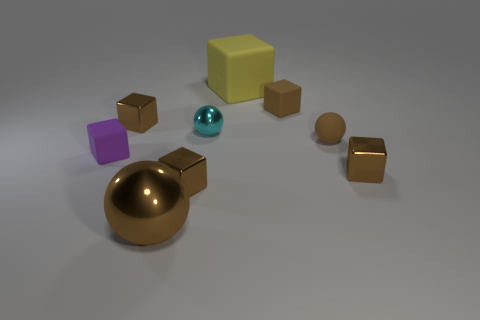Is the large metal ball the same color as the matte ball?
Offer a very short reply. Yes. How many other objects are there of the same color as the big metal thing?
Your response must be concise. 5. There is a tiny rubber cube on the right side of the yellow matte object; is its color the same as the rubber sphere?
Provide a succinct answer. Yes. There is a brown sphere that is the same size as the yellow block; what is it made of?
Your answer should be very brief. Metal. Is the number of blocks that are in front of the large cube the same as the number of small purple cubes that are behind the purple cube?
Your answer should be very brief. No. How many large brown objects are to the left of the tiny brown shiny cube that is to the left of the brown sphere to the left of the big yellow matte object?
Your answer should be compact. 0. Is the color of the matte sphere the same as the metallic block that is left of the big brown sphere?
Give a very brief answer. Yes. What is the size of the brown cube that is the same material as the purple cube?
Provide a succinct answer. Small. Are there more big things in front of the large yellow matte object than large red matte things?
Make the answer very short. Yes. There is a brown ball that is right of the small matte block that is right of the tiny brown metallic thing that is behind the cyan object; what is its material?
Ensure brevity in your answer.  Rubber. 